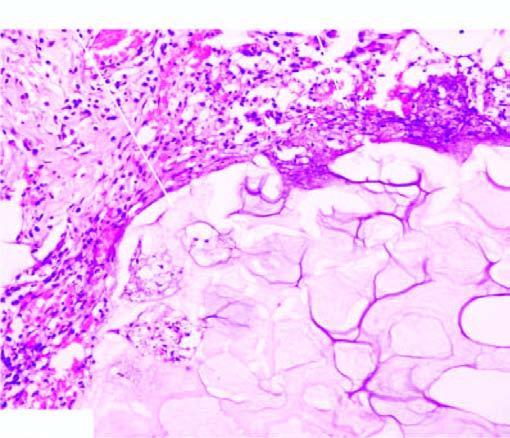what shows a few mixed inflammatory cells?
Answer the question using a single word or phrase. The periphery 